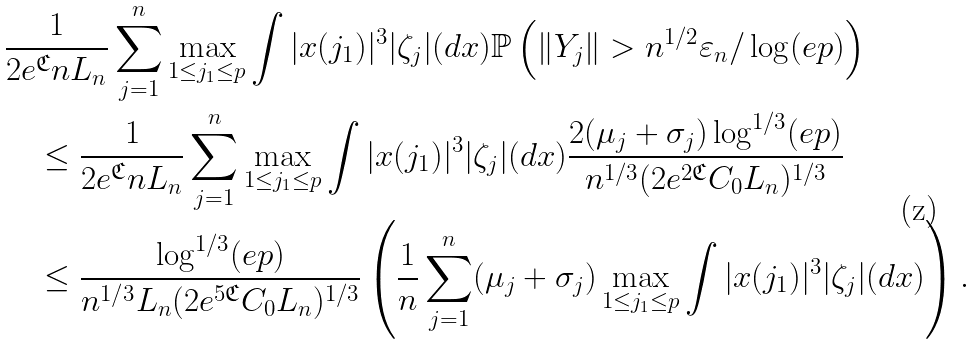<formula> <loc_0><loc_0><loc_500><loc_500>& \frac { 1 } { 2 e ^ { \mathfrak { C } } n L _ { n } } \sum _ { j = 1 } ^ { n } \max _ { 1 \leq j _ { 1 } \leq p } \int | x ( j _ { 1 } ) | ^ { 3 } | \zeta _ { j } | ( d x ) \mathbb { P } \left ( \| Y _ { j } \| > n ^ { 1 / 2 } \varepsilon _ { n } / \log ( e p ) \right ) \\ & \quad \leq \frac { 1 } { 2 e ^ { \mathfrak { C } } n L _ { n } } \sum _ { j = 1 } ^ { n } \max _ { 1 \leq j _ { 1 } \leq p } \int | x ( j _ { 1 } ) | ^ { 3 } | \zeta _ { j } | ( d x ) \frac { 2 ( \mu _ { j } + \sigma _ { j } ) \log ^ { 1 / 3 } ( e p ) } { n ^ { 1 / 3 } ( 2 e ^ { 2 \mathfrak { C } } C _ { 0 } L _ { n } ) ^ { 1 / 3 } } \\ & \quad \leq \frac { \log ^ { 1 / 3 } ( e p ) } { n ^ { 1 / 3 } L _ { n } ( 2 e ^ { 5 \mathfrak { C } } C _ { 0 } L _ { n } ) ^ { 1 / 3 } } \left ( \frac { 1 } { n } \sum _ { j = 1 } ^ { n } ( \mu _ { j } + \sigma _ { j } ) \max _ { 1 \leq j _ { 1 } \leq p } \int | x ( j _ { 1 } ) | ^ { 3 } | \zeta _ { j } | ( d x ) \right ) .</formula> 